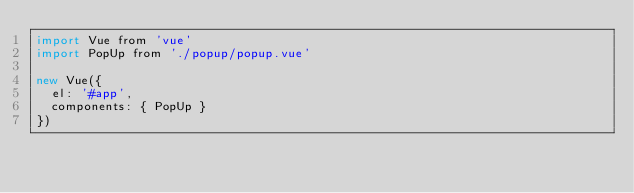Convert code to text. <code><loc_0><loc_0><loc_500><loc_500><_JavaScript_>import Vue from 'vue'
import PopUp from './popup/popup.vue'

new Vue({
  el: '#app',
  components: { PopUp }
})
</code> 